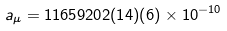<formula> <loc_0><loc_0><loc_500><loc_500>a _ { \mu } = 1 1 6 5 9 2 0 2 ( 1 4 ) ( 6 ) \times 1 0 ^ { - 1 0 }</formula> 